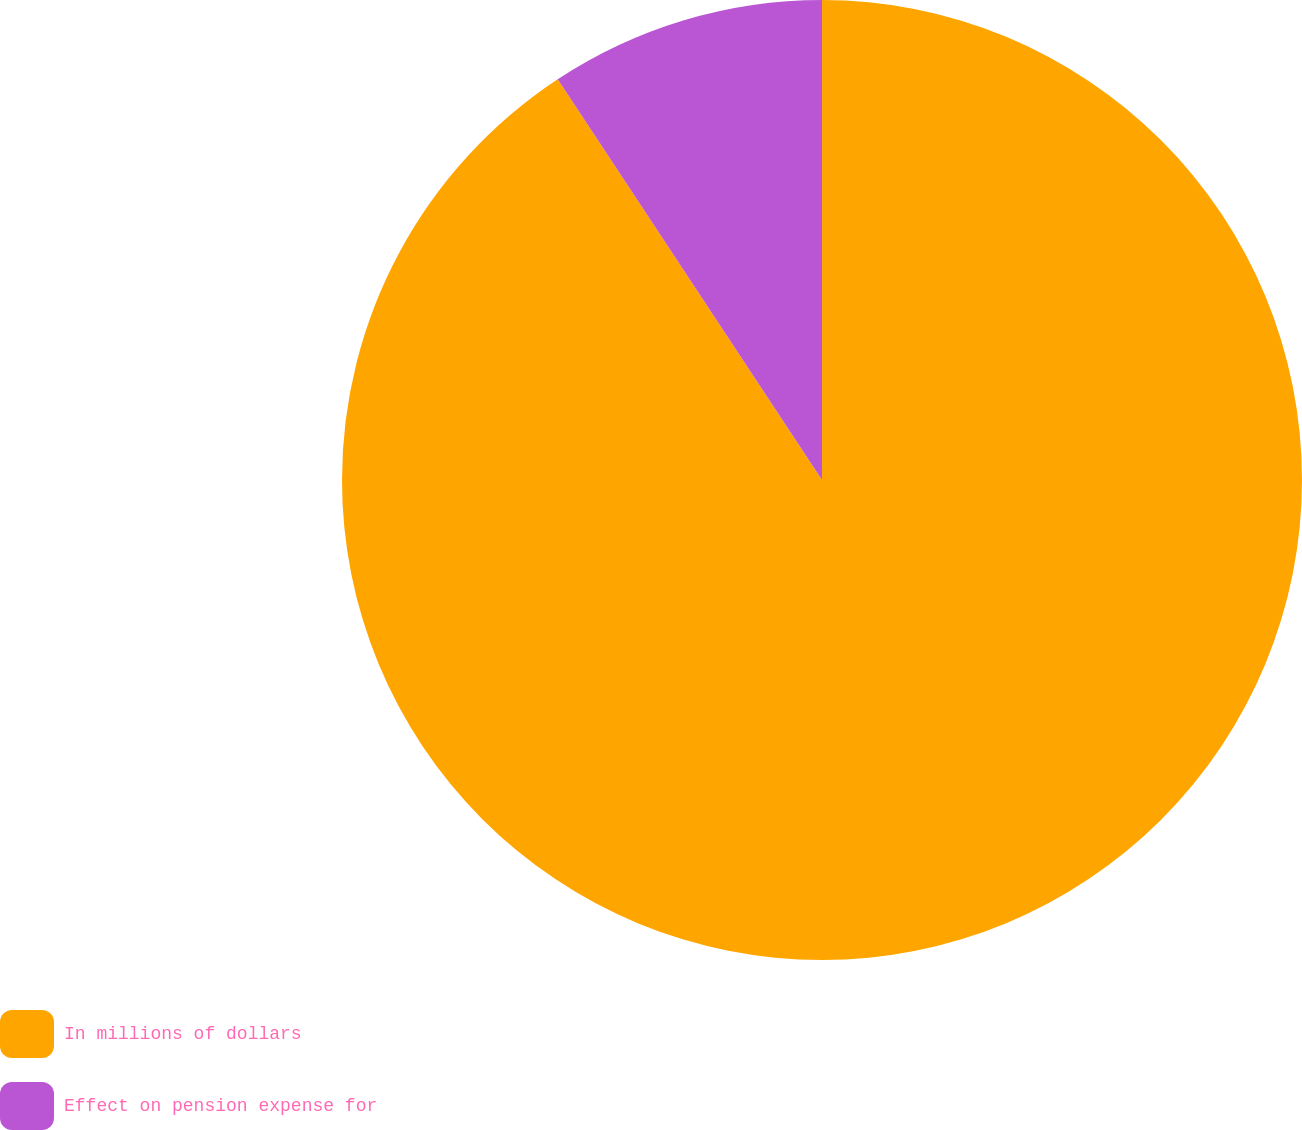<chart> <loc_0><loc_0><loc_500><loc_500><pie_chart><fcel>In millions of dollars<fcel>Effect on pension expense for<nl><fcel>90.72%<fcel>9.28%<nl></chart> 